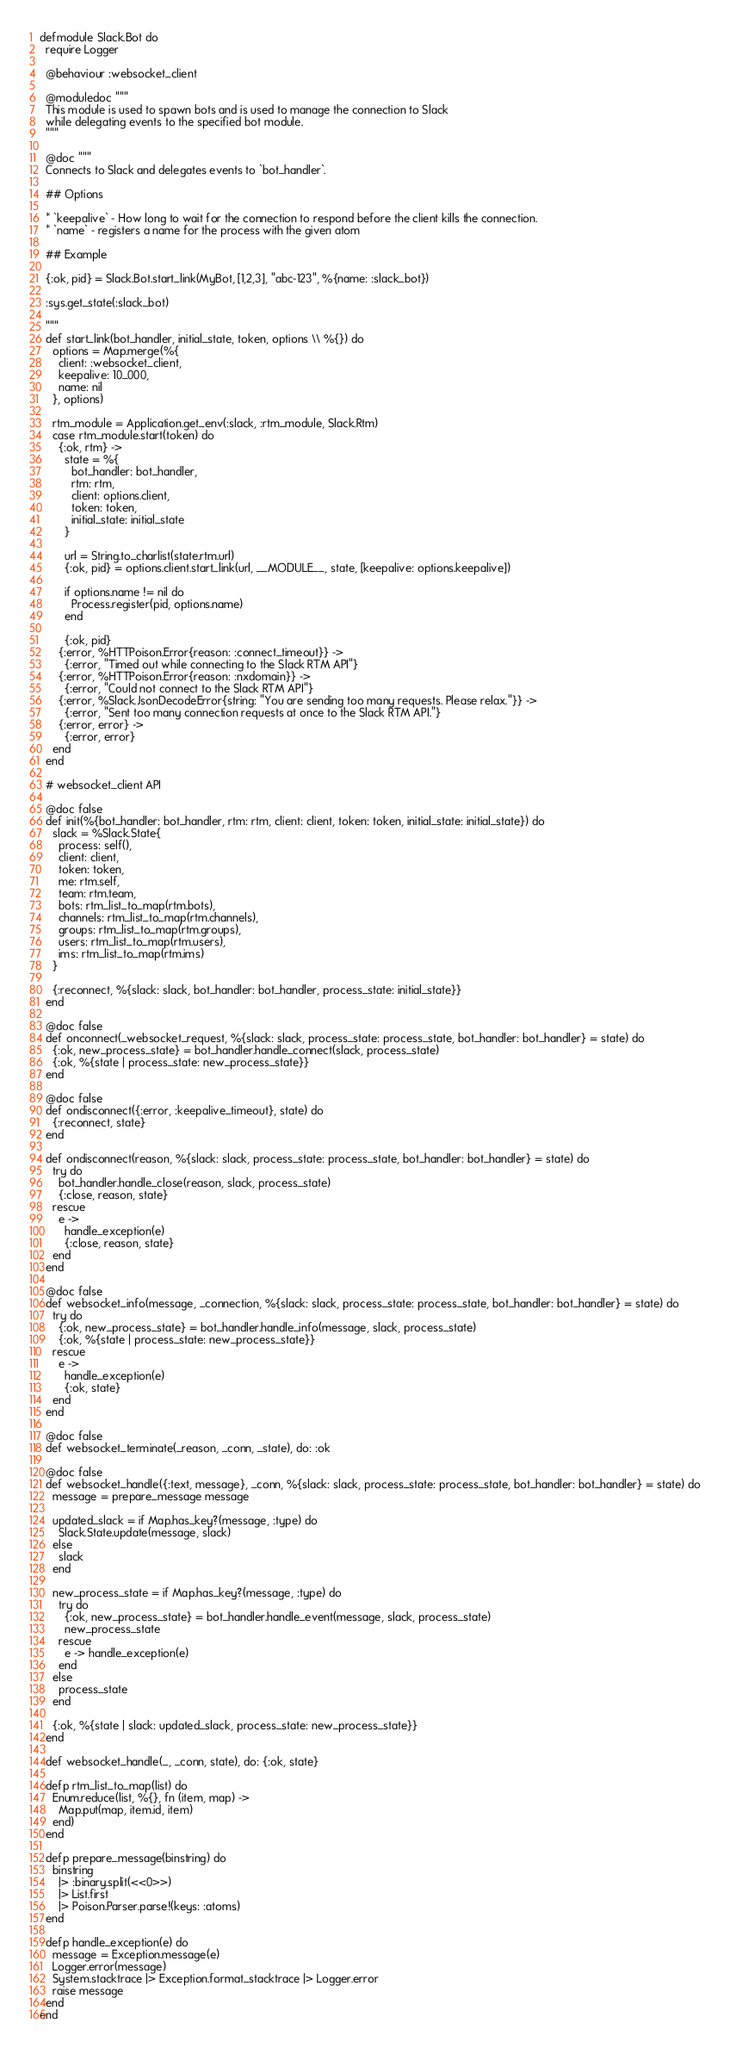<code> <loc_0><loc_0><loc_500><loc_500><_Elixir_>defmodule Slack.Bot do
  require Logger

  @behaviour :websocket_client

  @moduledoc """
  This module is used to spawn bots and is used to manage the connection to Slack
  while delegating events to the specified bot module.
  """

  @doc """
  Connects to Slack and delegates events to `bot_handler`.

  ## Options

  * `keepalive` - How long to wait for the connection to respond before the client kills the connection.
  * `name` - registers a name for the process with the given atom

  ## Example

  {:ok, pid} = Slack.Bot.start_link(MyBot, [1,2,3], "abc-123", %{name: :slack_bot})
  
  :sys.get_state(:slack_bot)
  
  """
  def start_link(bot_handler, initial_state, token, options \\ %{}) do
    options = Map.merge(%{
      client: :websocket_client,
      keepalive: 10_000,
      name: nil
    }, options)

    rtm_module = Application.get_env(:slack, :rtm_module, Slack.Rtm)
    case rtm_module.start(token) do
      {:ok, rtm} ->
        state = %{
          bot_handler: bot_handler,
          rtm: rtm,
          client: options.client,
          token: token,
          initial_state: initial_state
        }

        url = String.to_charlist(state.rtm.url)
        {:ok, pid} = options.client.start_link(url, __MODULE__, state, [keepalive: options.keepalive])

        if options.name != nil do
          Process.register(pid, options.name)
        end

        {:ok, pid}
      {:error, %HTTPoison.Error{reason: :connect_timeout}} ->
        {:error, "Timed out while connecting to the Slack RTM API"}
      {:error, %HTTPoison.Error{reason: :nxdomain}} ->
        {:error, "Could not connect to the Slack RTM API"}
      {:error, %Slack.JsonDecodeError{string: "You are sending too many requests. Please relax."}} ->
        {:error, "Sent too many connection requests at once to the Slack RTM API."}
      {:error, error} ->
        {:error, error}
    end
  end

  # websocket_client API

  @doc false
  def init(%{bot_handler: bot_handler, rtm: rtm, client: client, token: token, initial_state: initial_state}) do
    slack = %Slack.State{
      process: self(),
      client: client,
      token: token,
      me: rtm.self,
      team: rtm.team,
      bots: rtm_list_to_map(rtm.bots),
      channels: rtm_list_to_map(rtm.channels),
      groups: rtm_list_to_map(rtm.groups),
      users: rtm_list_to_map(rtm.users),
      ims: rtm_list_to_map(rtm.ims)
    }

    {:reconnect, %{slack: slack, bot_handler: bot_handler, process_state: initial_state}}
  end

  @doc false
  def onconnect(_websocket_request, %{slack: slack, process_state: process_state, bot_handler: bot_handler} = state) do
    {:ok, new_process_state} = bot_handler.handle_connect(slack, process_state)
    {:ok, %{state | process_state: new_process_state}}
  end

  @doc false
  def ondisconnect({:error, :keepalive_timeout}, state) do
    {:reconnect, state}
  end

  def ondisconnect(reason, %{slack: slack, process_state: process_state, bot_handler: bot_handler} = state) do
    try do
      bot_handler.handle_close(reason, slack, process_state)
      {:close, reason, state}
    rescue
      e ->
        handle_exception(e)
        {:close, reason, state}
    end
  end

  @doc false
  def websocket_info(message, _connection, %{slack: slack, process_state: process_state, bot_handler: bot_handler} = state) do
    try do
      {:ok, new_process_state} = bot_handler.handle_info(message, slack, process_state)
      {:ok, %{state | process_state: new_process_state}}
    rescue
      e ->
        handle_exception(e)
        {:ok, state}
    end
  end

  @doc false
  def websocket_terminate(_reason, _conn, _state), do: :ok

  @doc false
  def websocket_handle({:text, message}, _conn, %{slack: slack, process_state: process_state, bot_handler: bot_handler} = state) do
    message = prepare_message message

    updated_slack = if Map.has_key?(message, :type) do
      Slack.State.update(message, slack)
    else
      slack
    end

    new_process_state = if Map.has_key?(message, :type) do
      try do
        {:ok, new_process_state} = bot_handler.handle_event(message, slack, process_state)
        new_process_state
      rescue
        e -> handle_exception(e)
      end
    else
      process_state
    end

    {:ok, %{state | slack: updated_slack, process_state: new_process_state}}
  end

  def websocket_handle(_, _conn, state), do: {:ok, state}

  defp rtm_list_to_map(list) do
    Enum.reduce(list, %{}, fn (item, map) ->
      Map.put(map, item.id, item)
    end)
  end

  defp prepare_message(binstring) do
    binstring
      |> :binary.split(<<0>>)
      |> List.first
      |> Poison.Parser.parse!(keys: :atoms)
  end

  defp handle_exception(e) do
    message = Exception.message(e)
    Logger.error(message)
    System.stacktrace |> Exception.format_stacktrace |> Logger.error
    raise message
  end
end
</code> 